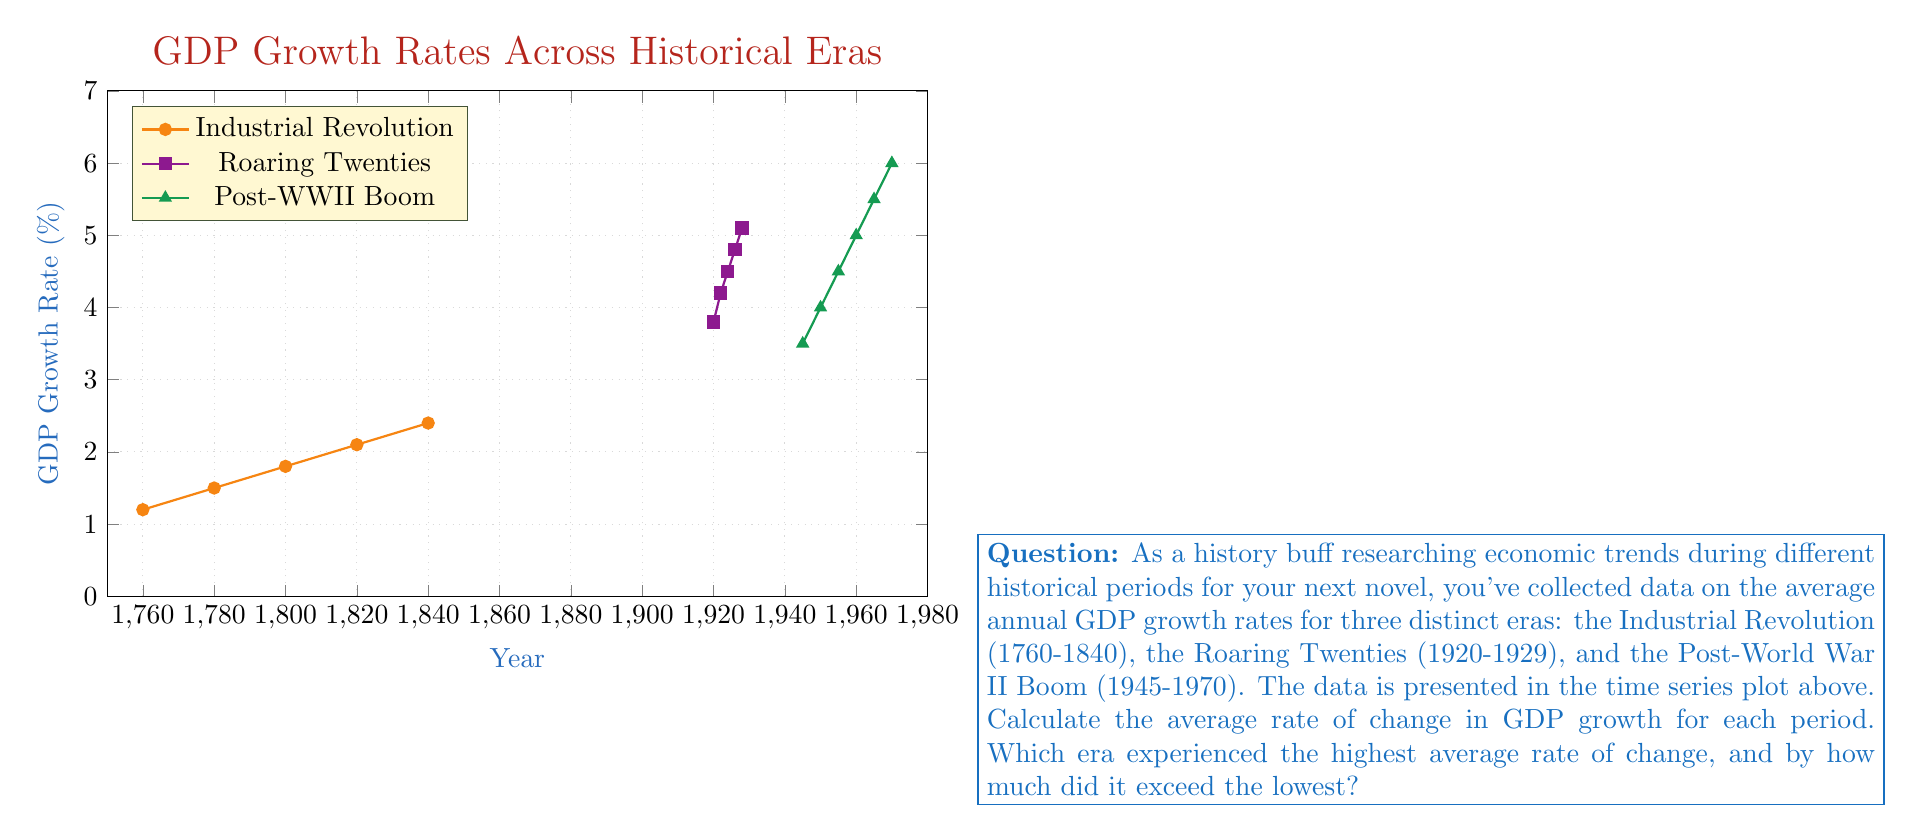What is the answer to this math problem? To solve this problem, we need to calculate the average rate of change for each period and then compare them. The average rate of change is given by the formula:

$$ \text{Average Rate of Change} = \frac{\text{Change in y}}{\text{Change in x}} = \frac{y_2 - y_1}{x_2 - x_1} $$

1. Industrial Revolution (1760-1840):
   $$ \text{Rate} = \frac{2.4\% - 1.2\%}{1840 - 1760} = \frac{1.2\%}{80 \text{ years}} = 0.015\% \text{ per year} $$

2. Roaring Twenties (1920-1929):
   $$ \text{Rate} = \frac{5.1\% - 3.8\%}{1928 - 1920} = \frac{1.3\%}{8 \text{ years}} = 0.1625\% \text{ per year} $$

3. Post-World War II Boom (1945-1970):
   $$ \text{Rate} = \frac{6.0\% - 3.5\%}{1970 - 1945} = \frac{2.5\%}{25 \text{ years}} = 0.1\% \text{ per year} $$

The Roaring Twenties had the highest average rate of change at 0.1625% per year, while the Industrial Revolution had the lowest at 0.015% per year.

The difference between the highest and lowest rates:
$$ 0.1625\% - 0.015\% = 0.1475\% \text{ per year} $$
Answer: The Roaring Twenties; 0.1475% per year 